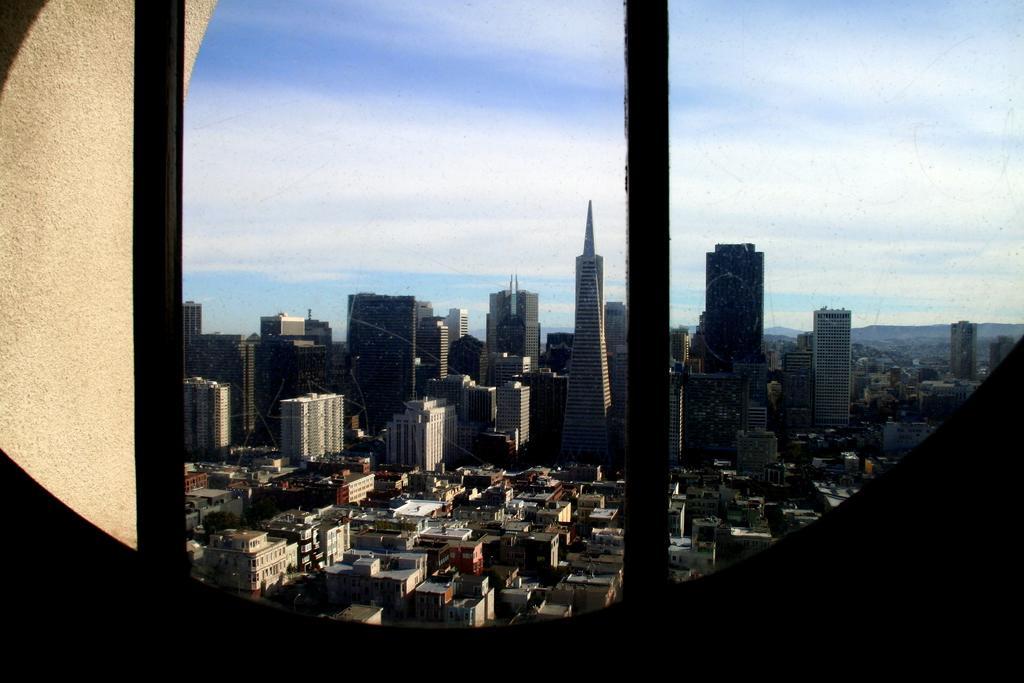Can you describe this image briefly? In this image I see number of buildings and I see the clear sky and I see the wall over here. 